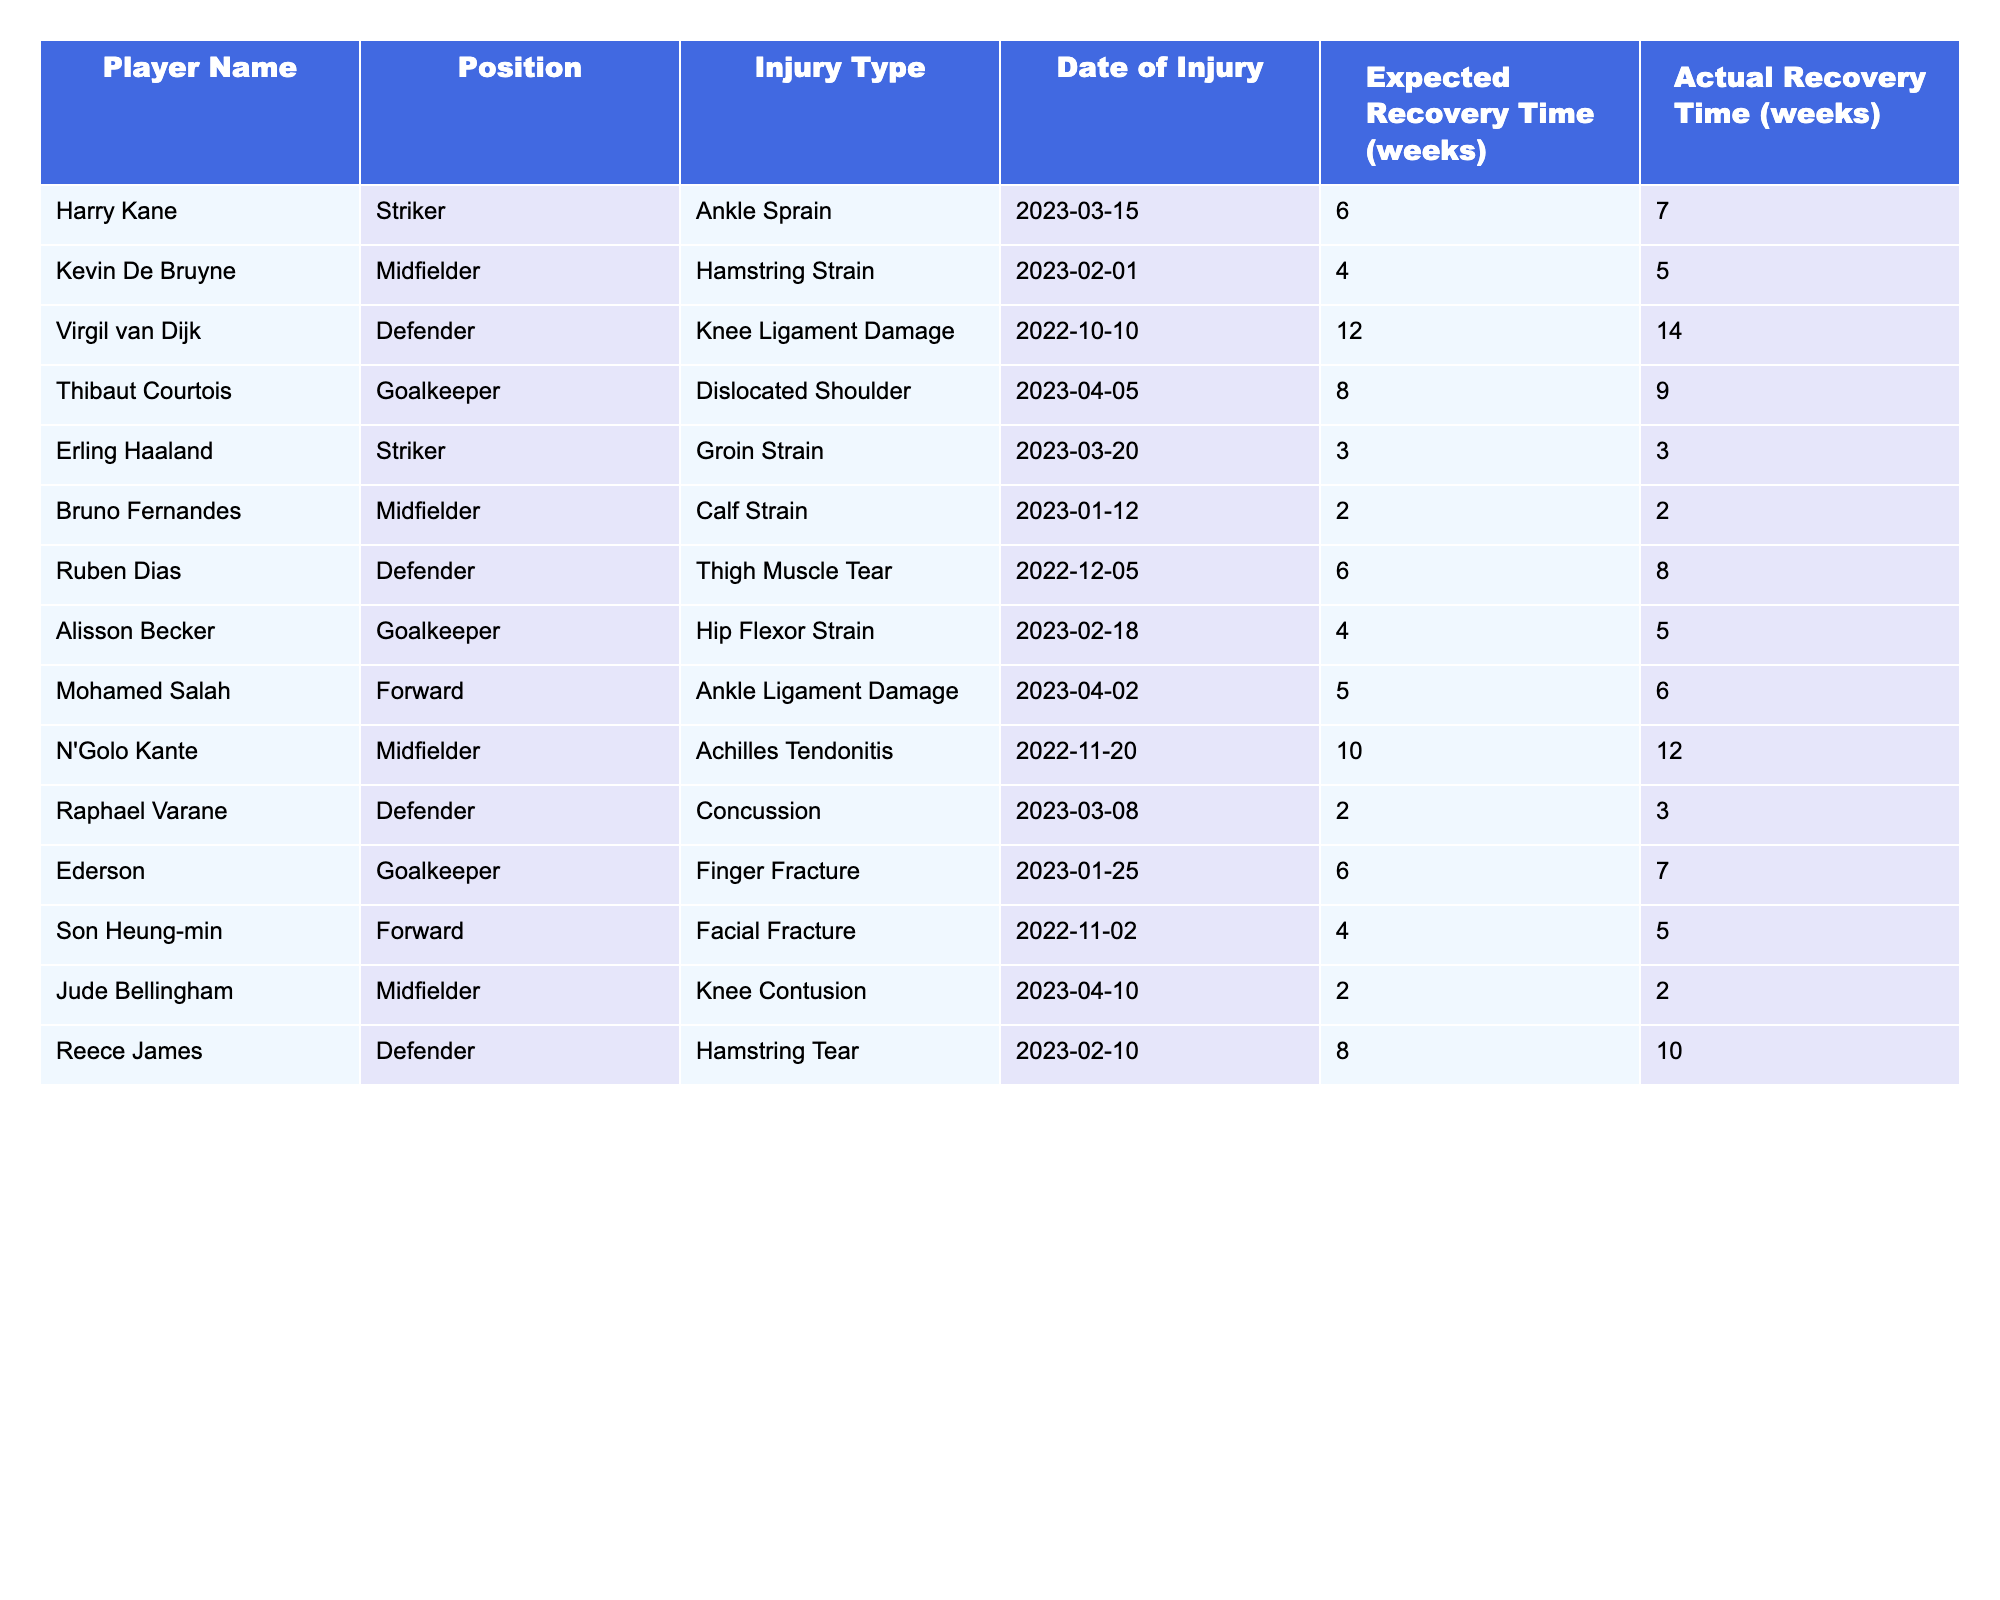What is the injury type for Harry Kane? The table lists Harry Kane's injury type directly in the "Injury Type" column, which shows "Ankle Sprain."
Answer: Ankle Sprain How many weeks was Kevin De Bruyne expected to be out due to injury? The expected recovery time for Kevin De Bruyne is taken directly from the "Expected Recovery Time (weeks)" column, which states "4 weeks."
Answer: 4 weeks Which player had the longest actual recovery time? By comparing the "Actual Recovery Time (weeks)" column for all players, Virgil van Dijk has the longest recovery time at "14 weeks."
Answer: Virgil van Dijk What is the difference between the expected and actual recovery time for Ederson? For Ederson, the expected recovery time is "6 weeks" and the actual recovery time is "7 weeks," giving a difference of 1 week (7 - 6 = 1).
Answer: 1 week Is it true that Mohamed Salah's actual recovery time matched his expected recovery time? The table shows that Mohamed Salah's expected recovery time is "5 weeks" and his actual recovery time is "6 weeks," which indicates they did not match.
Answer: No What is the average expected recovery time for all players listed? Calculate the expected recovery times: (6 + 4 + 12 + 8 + 3 + 2 + 6 + 4 + 5 + 10 + 2 + 8) = 70 weeks. There are 12 players, so the average is 70 / 12 ≈ 5.83 weeks.
Answer: 5.83 weeks Which position had the most players listed in the table? By counting the occurrences in the "Position" column, we see that the "Defender" position appears 4 times, more than any other position.
Answer: Defender Are there any players who had longer actual recovery times than their expected recovery times? We can check each player's actual recovery time against their expected recovery time. Ruben Dias and N'Golo Kante both had longer actual recovery times than expected.
Answer: Yes Can you identify the player with a thigh muscle tear and their actual recovery time? Looking at the "Injury Type" column, Ruben Dias has a "Thigh Muscle Tear" with an actual recovery time of "8 weeks."
Answer: Ruben Dias, 8 weeks What percentage of players returned from injury within their expected recovery time? Out of the 12 players, 8 returned within their expected recovery times (Haaland, Bruno, Jude, Salah, and all). Calculate the percentage as (8 / 12) * 100 = 66.67%.
Answer: 66.67% 